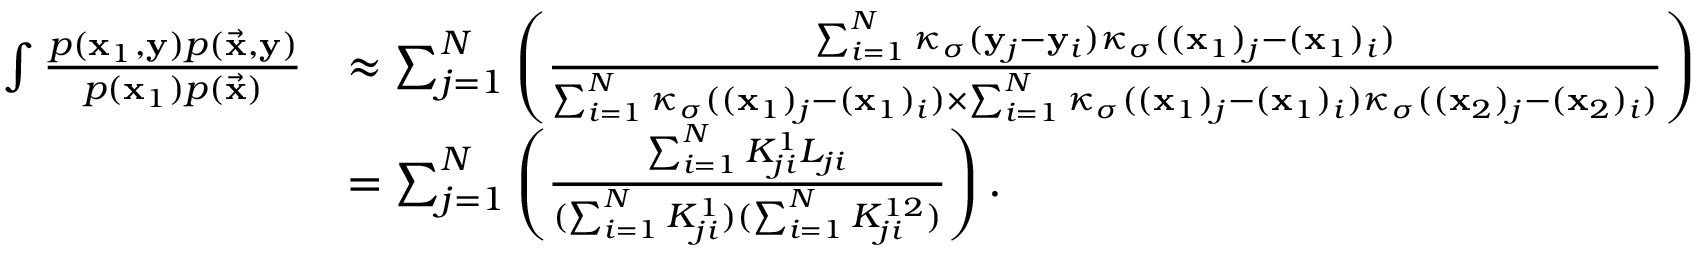Convert formula to latex. <formula><loc_0><loc_0><loc_500><loc_500>\begin{array} { r l } { \int \frac { p ( x _ { 1 } , y ) p ( \vec { x } , y ) } { p ( x _ { 1 } ) p ( \vec { x } ) } } & { \approx \sum _ { j = 1 } ^ { N } \left ( \frac { \sum _ { i = 1 } ^ { N } \kappa _ { \sigma } ( y _ { j } - y _ { i } ) \kappa _ { \sigma } ( ( x _ { 1 } ) _ { j } - ( x _ { 1 } ) _ { i } ) } { \sum _ { i = 1 } ^ { N } \kappa _ { \sigma } ( ( x _ { 1 } ) _ { j } - ( x _ { 1 } ) _ { i } ) \times \sum _ { i = 1 } ^ { N } \kappa _ { \sigma } ( ( x _ { 1 } ) _ { j } - ( x _ { 1 } ) _ { i } ) \kappa _ { \sigma } ( ( x _ { 2 } ) _ { j } - ( x _ { 2 } ) _ { i } ) } \right ) } \\ & { = \sum _ { j = 1 } ^ { N } \left ( \frac { \sum _ { i = 1 } ^ { N } K _ { j i } ^ { 1 } L _ { j i } } { ( \sum _ { i = 1 } ^ { N } K _ { j i } ^ { 1 } ) ( \sum _ { i = 1 } ^ { N } K _ { j i } ^ { 1 2 } ) } \right ) . } \end{array}</formula> 